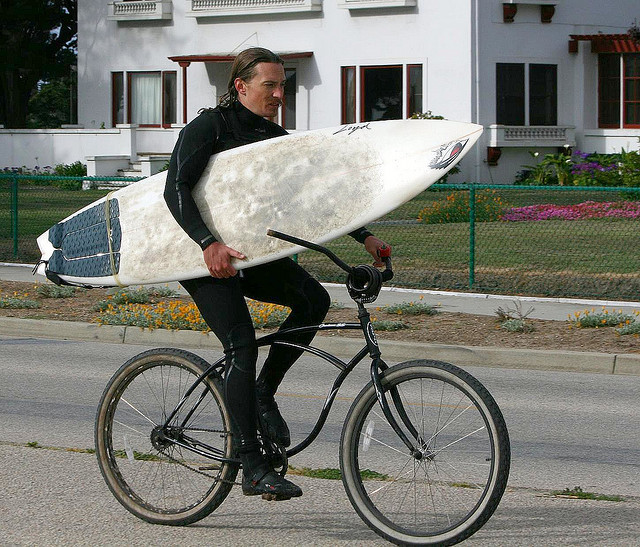<image>How long is the surfboard? It is unknown how long the surfboard is. It can be anywhere from 5 feet to 8 feet. How long is the surfboard? I don't know how long the surfboard is. It can be anywhere from 5 to 8 feet. 